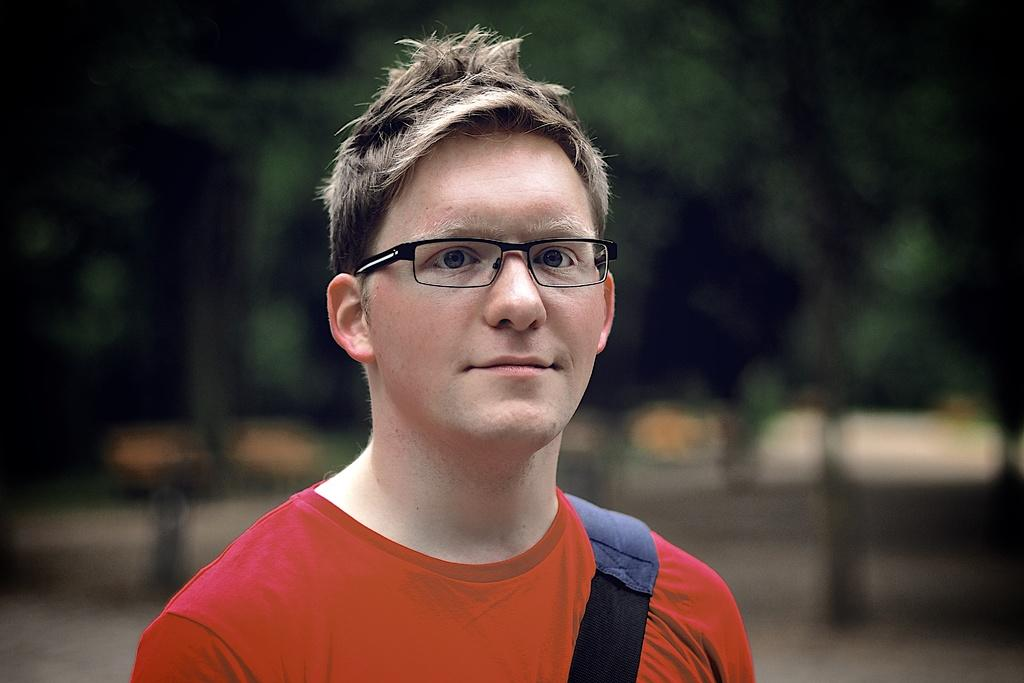Who or what is the main subject of the image? There is a person in the image. What is the person wearing? The person is wearing a red t-shirt and black-colored spectacles. Can you describe the background of the image? The background of the image is blurry, but trees and other objects are visible. What type of religious ceremony is taking place in the image? There is no indication of a religious ceremony in the image; it features a person wearing a red t-shirt and black-colored spectacles with a blurry background. What is the person using to boil water in the image? There is no kettle or any indication of boiling water in the image. 